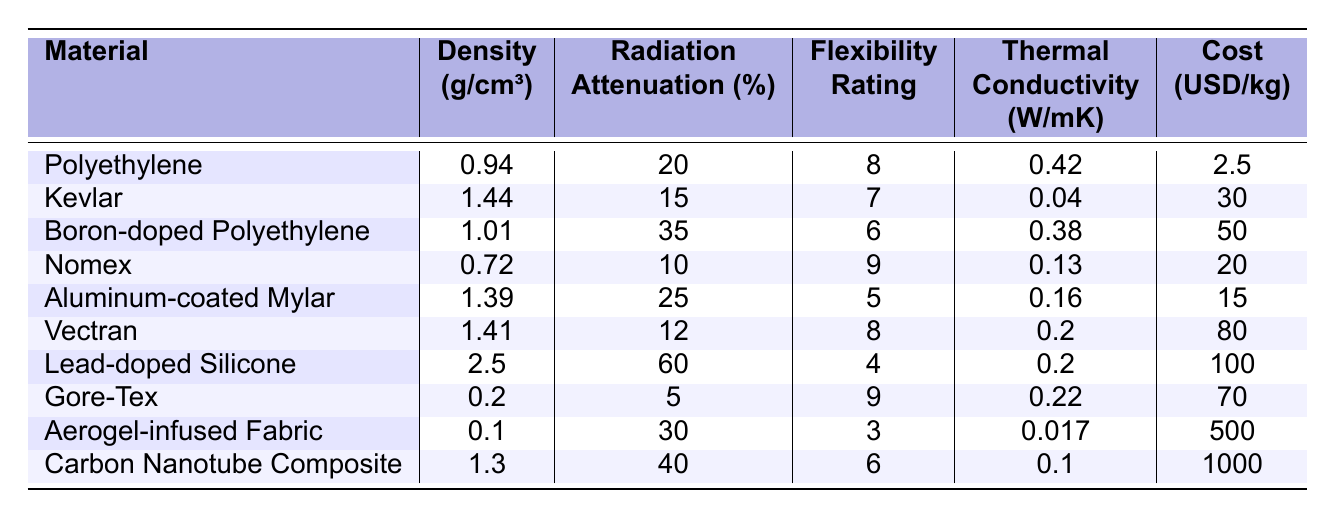What is the density of Lead-doped Silicone? Looking at the table, the density of Lead-doped Silicone is listed directly in the column for density.
Answer: 2.5 g/cm³ Which material has the highest radiation attenuation percentage? By observing the radiation attenuation percentage column, Lead-doped Silicone has the highest value listed at 60%.
Answer: Lead-doped Silicone What is the cost per kilogram for Carbon Nanotube Composite? The cost per kilogram for Carbon Nanotube Composite is found in the cost column, where it is listed at 1000 USD/kg.
Answer: 1000 USD/kg Is Nomex the most flexible material? Checking the flexibility rating, Nomex has a rating of 9, but so does Gore-Tex. Therefore, Nomex is not the most flexible material since there is a tie.
Answer: No Calculate the average density of all listed materials. The sum of the densities is (0.94 + 1.44 + 1.01 + 0.72 + 1.39 + 1.41 + 2.5 + 0.2 + 0.1 + 1.3) = 10.82 g/cm³. Dividing this sum by 10 (the number of materials), gives an average density of 1.082 g/cm³.
Answer: 1.082 g/cm³ Which materials have a flexibility rating of 8 or higher? Checking the flexibility ratings, Polyethylene (8), Nomex (9), Vectran (8), and Gore-Tex (9) all have ratings of 8 or higher.
Answer: Polyethylene, Nomex, Vectran, Gore-Tex Which material has the lowest thermal conductivity? Looking at the thermal conductivity column, Aerogel-infused Fabric has the lowest value listed at 0.017 W/mK.
Answer: Aerogel-infused Fabric Is it true that all materials with a flexibility rating of 4 or lower have a radiation attenuation percentage above 20%? Examining the table, the only material with a flexibility rating of 4 is Lead-doped Silicone, which has a radiation attenuation percentage of 60%, satisfying the condition, while other materials with ratings above 4 have both higher and lower attenuation percentages. Thus, the statement is true.
Answer: Yes How much more does Carbon Nanotube Composite cost per kilogram than Polyethylene? The cost of Carbon Nanotube Composite is 1000 USD/kg and that of Polyethylene is 2.5 USD/kg. The difference is 1000 - 2.5 = 997.5 USD/kg, indicating how much more it costs.
Answer: 997.5 USD/kg What is the median flexibility rating of the materials? The flexibility ratings are: 8, 7, 6, 9, 5, 8, 4, 9, 3, 6. When ordered from lowest to highest: 3, 4, 5, 6, 6, 7, 8, 8, 9, 9. The median (the average of the 5th and 6th values) is (6 + 7)/2 = 6.5.
Answer: 6.5 